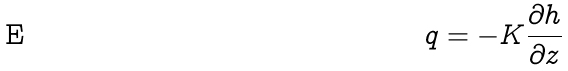<formula> <loc_0><loc_0><loc_500><loc_500>q = - K \frac { \partial h } { \partial z }</formula> 